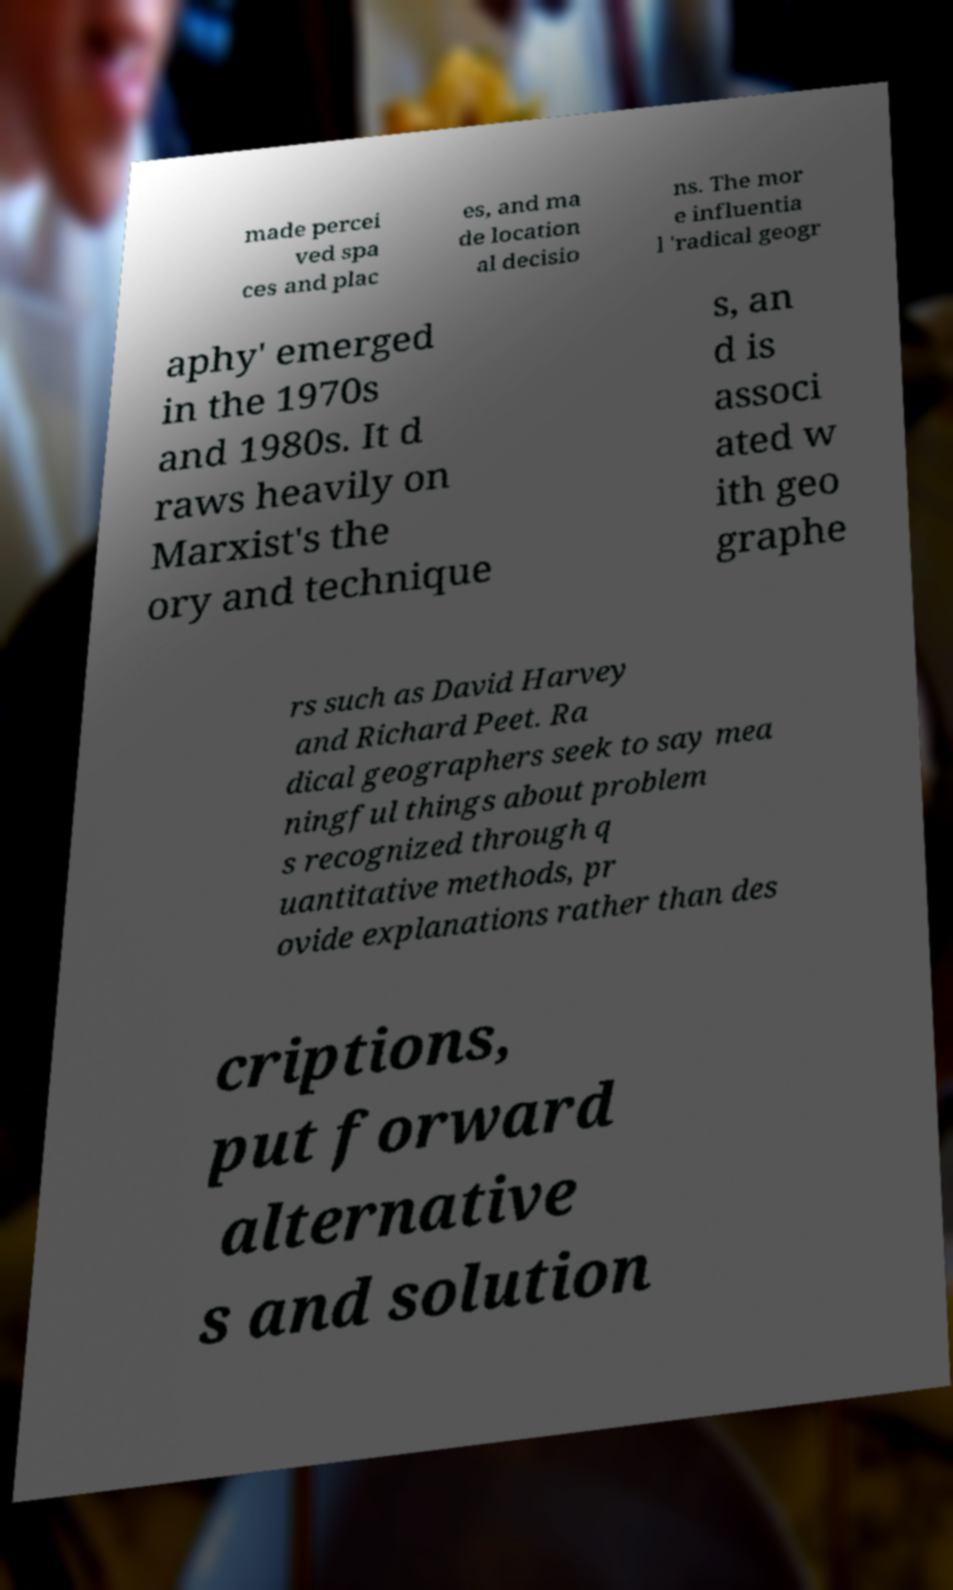Could you extract and type out the text from this image? made percei ved spa ces and plac es, and ma de location al decisio ns. The mor e influentia l 'radical geogr aphy' emerged in the 1970s and 1980s. It d raws heavily on Marxist's the ory and technique s, an d is associ ated w ith geo graphe rs such as David Harvey and Richard Peet. Ra dical geographers seek to say mea ningful things about problem s recognized through q uantitative methods, pr ovide explanations rather than des criptions, put forward alternative s and solution 